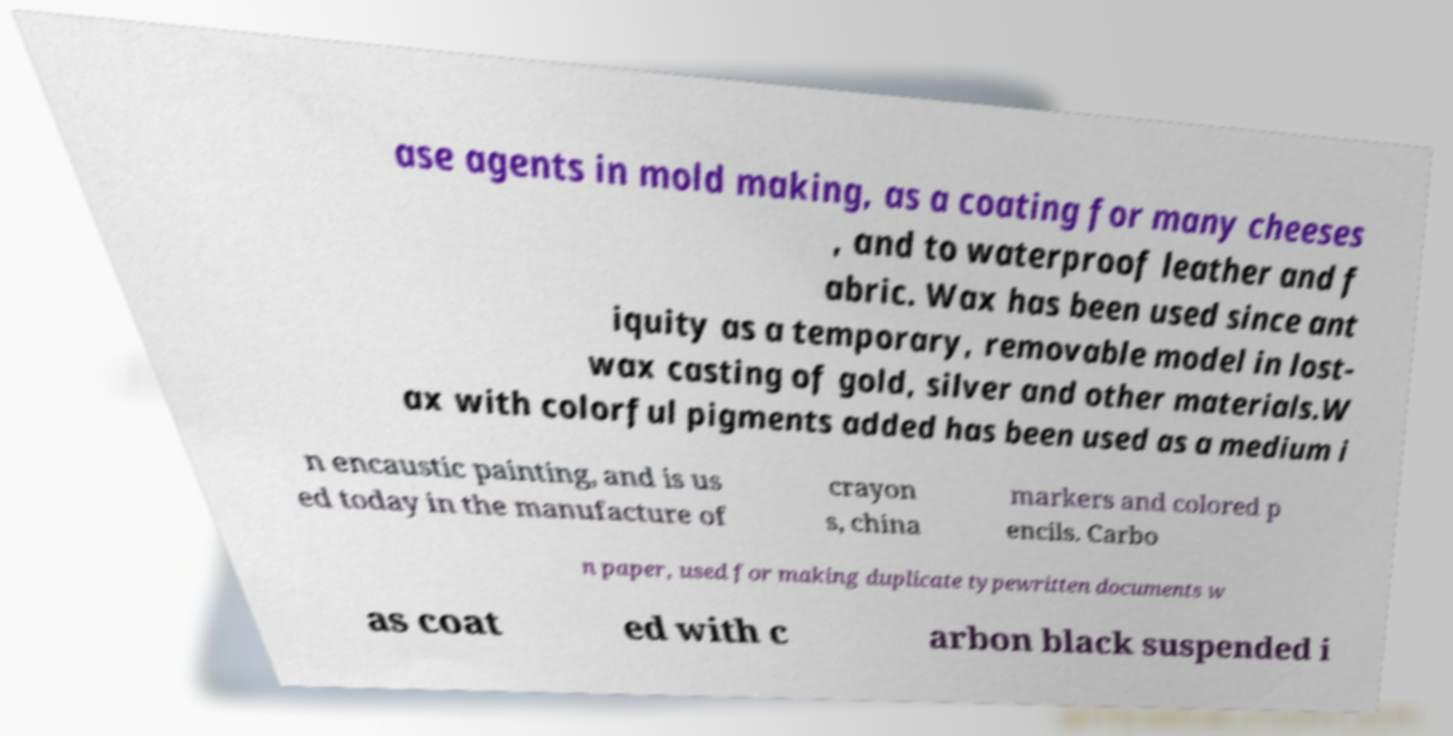What messages or text are displayed in this image? I need them in a readable, typed format. ase agents in mold making, as a coating for many cheeses , and to waterproof leather and f abric. Wax has been used since ant iquity as a temporary, removable model in lost- wax casting of gold, silver and other materials.W ax with colorful pigments added has been used as a medium i n encaustic painting, and is us ed today in the manufacture of crayon s, china markers and colored p encils. Carbo n paper, used for making duplicate typewritten documents w as coat ed with c arbon black suspended i 